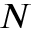Convert formula to latex. <formula><loc_0><loc_0><loc_500><loc_500>N</formula> 